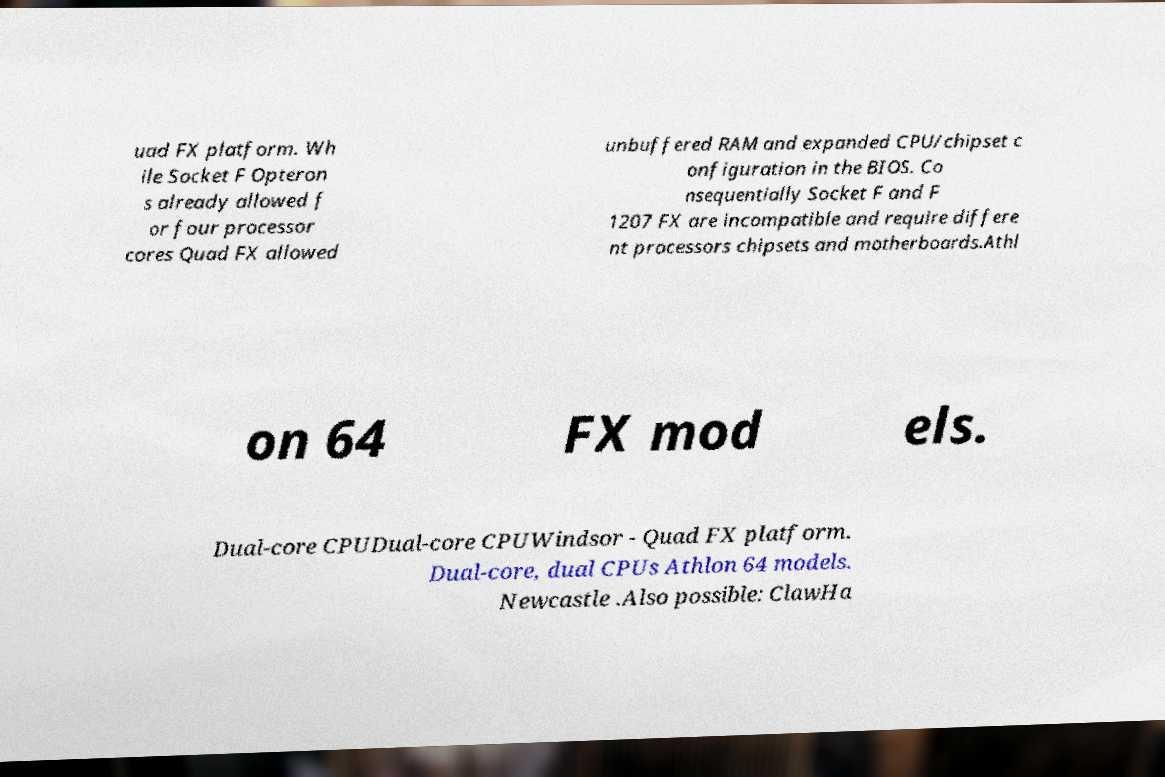Could you extract and type out the text from this image? uad FX platform. Wh ile Socket F Opteron s already allowed f or four processor cores Quad FX allowed unbuffered RAM and expanded CPU/chipset c onfiguration in the BIOS. Co nsequentially Socket F and F 1207 FX are incompatible and require differe nt processors chipsets and motherboards.Athl on 64 FX mod els. Dual-core CPUDual-core CPUWindsor - Quad FX platform. Dual-core, dual CPUs Athlon 64 models. Newcastle .Also possible: ClawHa 